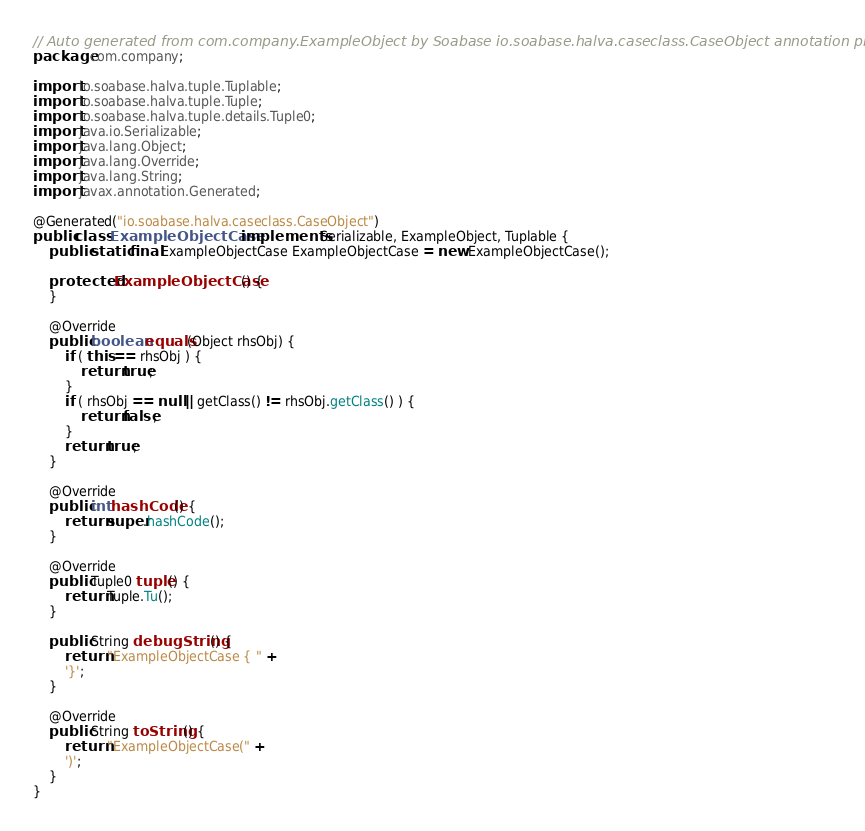Convert code to text. <code><loc_0><loc_0><loc_500><loc_500><_Java_>// Auto generated from com.company.ExampleObject by Soabase io.soabase.halva.caseclass.CaseObject annotation processor
package com.company;

import io.soabase.halva.tuple.Tuplable;
import io.soabase.halva.tuple.Tuple;
import io.soabase.halva.tuple.details.Tuple0;
import java.io.Serializable;
import java.lang.Object;
import java.lang.Override;
import java.lang.String;
import javax.annotation.Generated;

@Generated("io.soabase.halva.caseclass.CaseObject")
public class ExampleObjectCase implements Serializable, ExampleObject, Tuplable {
    public static final ExampleObjectCase ExampleObjectCase = new ExampleObjectCase();

    protected ExampleObjectCase() {
    }

    @Override
    public boolean equals(Object rhsObj) {
        if ( this == rhsObj ) {
            return true;
        }
        if ( rhsObj == null || getClass() != rhsObj.getClass() ) {
            return false;
        }
        return true;
    }

    @Override
    public int hashCode() {
        return super.hashCode();
    }

    @Override
    public Tuple0 tuple() {
        return Tuple.Tu();
    }

    public String debugString() {
        return "ExampleObjectCase { " +
        '}';
    }

    @Override
    public String toString() {
        return "ExampleObjectCase(" +
        ')';
    }
}
</code> 